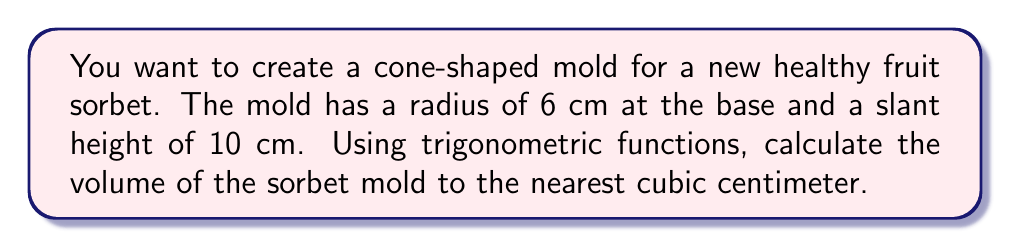Could you help me with this problem? To solve this problem, we need to follow these steps:

1. First, we need to find the height of the cone using the given slant height and radius.
2. Then, we'll use the volume formula for a cone to calculate the volume.

Let's begin:

1. Finding the height of the cone:
   We can use the Pythagorean theorem to find the height. Let's call the height $h$.
   
   $$h^2 + r^2 = s^2$$
   
   Where $r$ is the radius (6 cm) and $s$ is the slant height (10 cm).
   
   $$h^2 + 6^2 = 10^2$$
   $$h^2 + 36 = 100$$
   $$h^2 = 64$$
   $$h = 8\text{ cm}$$

2. Now that we have the height, we can use the volume formula for a cone:
   
   $$V = \frac{1}{3}\pi r^2 h$$

   Where $V$ is the volume, $r$ is the radius, and $h$ is the height.

   Substituting our values:
   
   $$V = \frac{1}{3}\pi (6\text{ cm})^2 (8\text{ cm})$$
   $$V = \frac{1}{3}\pi (36\text{ cm}^2) (8\text{ cm})$$
   $$V = 96\pi\text{ cm}^3$$

3. Calculating the final result:
   
   $$V = 96 \times 3.14159... \approx 301.59\text{ cm}^3$$

Rounding to the nearest cubic centimeter, we get 302 cm³.

[asy]
import geometry;

size(200);
pair A = (0,0), B = (6,0), C = (0,8);
draw(A--B--C--A);
draw(B--(0,8),dashed);
label("10 cm", (3,4), E);
label("6 cm", (3,0), S);
label("8 cm", (0,4), W);
[/asy]
Answer: The volume of the cone-shaped sorbet mold is approximately 302 cm³. 